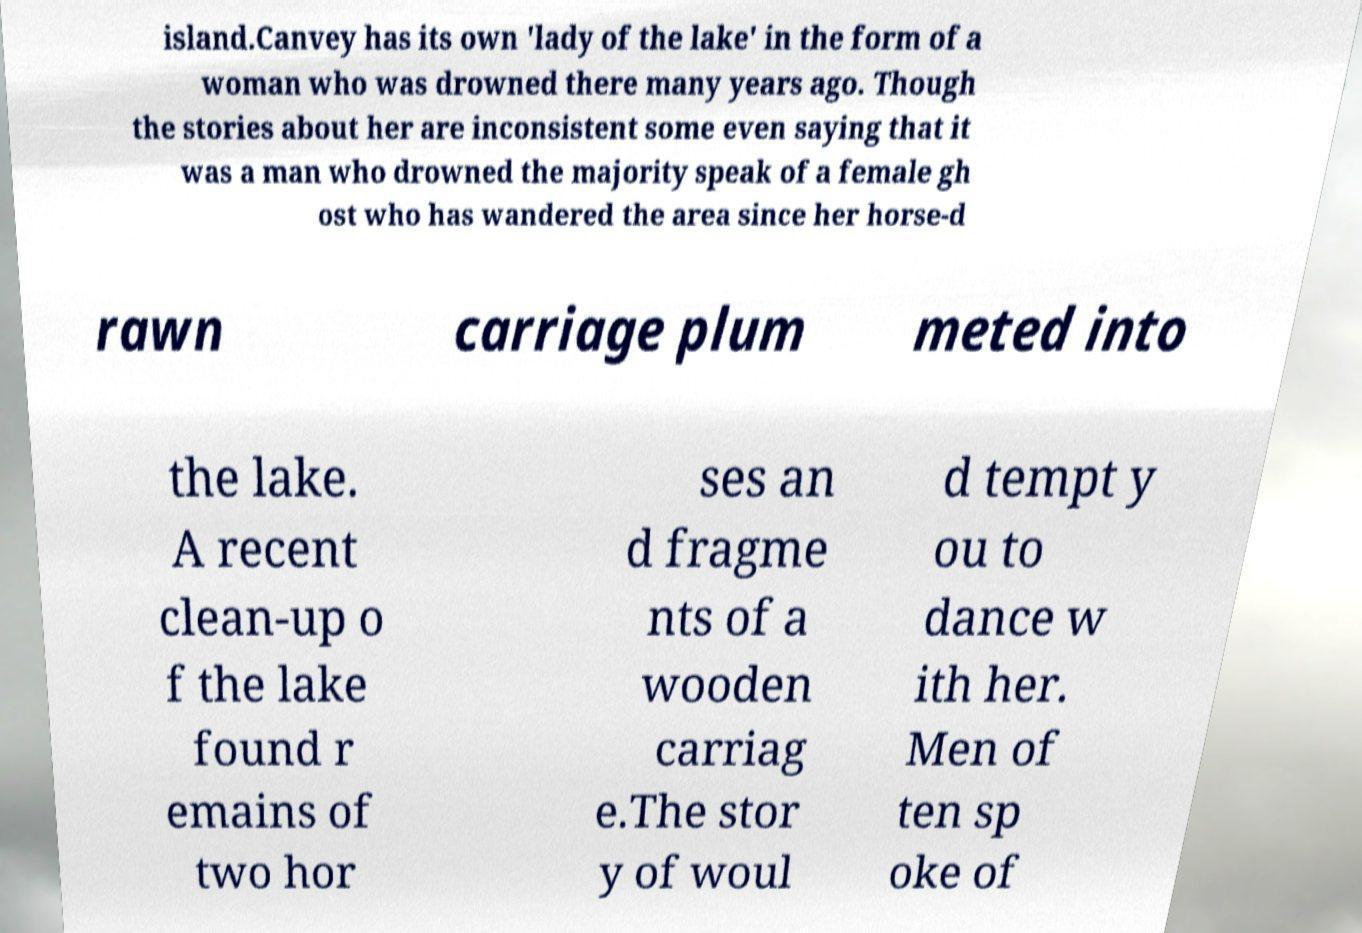There's text embedded in this image that I need extracted. Can you transcribe it verbatim? island.Canvey has its own 'lady of the lake' in the form of a woman who was drowned there many years ago. Though the stories about her are inconsistent some even saying that it was a man who drowned the majority speak of a female gh ost who has wandered the area since her horse-d rawn carriage plum meted into the lake. A recent clean-up o f the lake found r emains of two hor ses an d fragme nts of a wooden carriag e.The stor y of woul d tempt y ou to dance w ith her. Men of ten sp oke of 